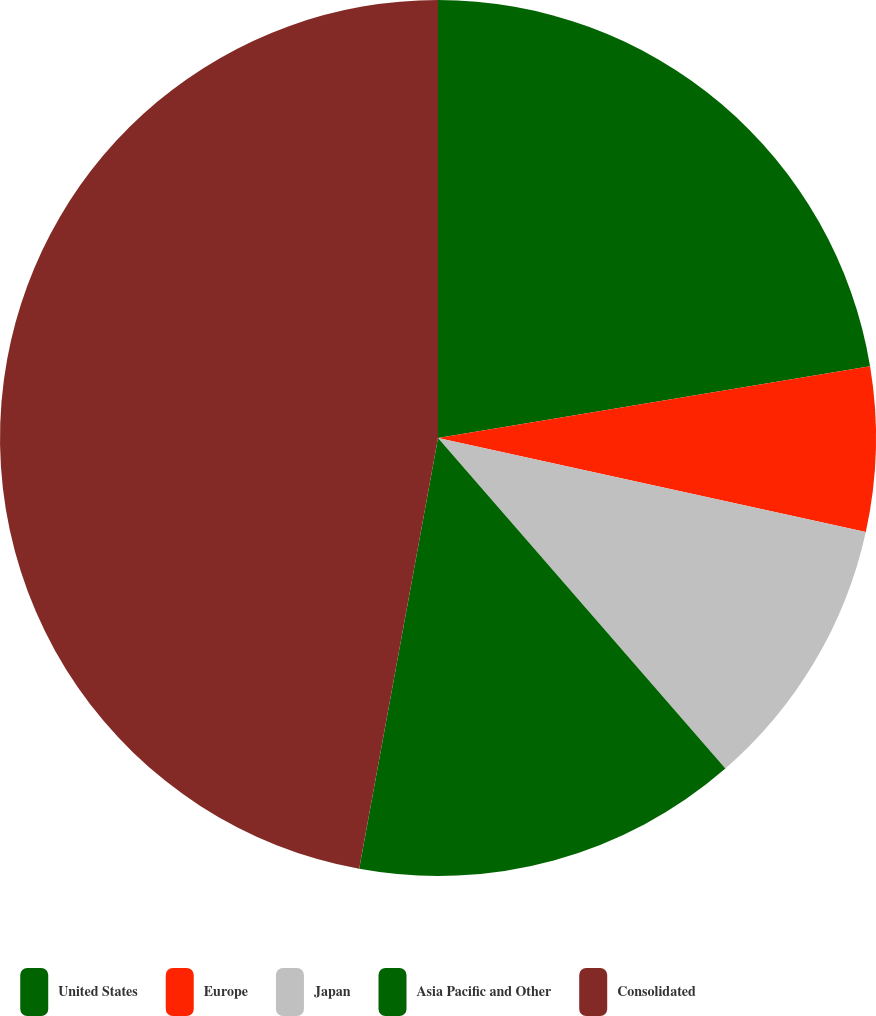Convert chart to OTSL. <chart><loc_0><loc_0><loc_500><loc_500><pie_chart><fcel>United States<fcel>Europe<fcel>Japan<fcel>Asia Pacific and Other<fcel>Consolidated<nl><fcel>22.38%<fcel>6.06%<fcel>10.17%<fcel>14.27%<fcel>47.12%<nl></chart> 